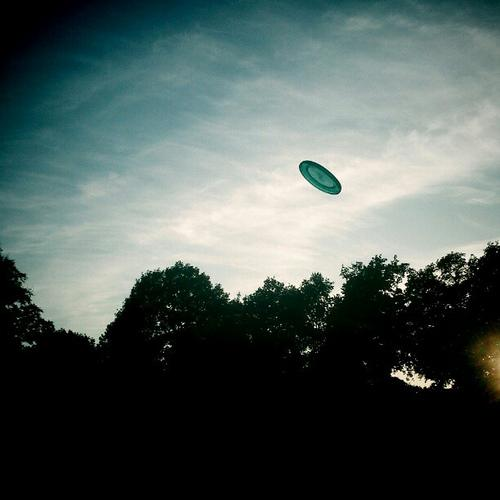How would you describe the appearance of the sky in the image? The sky is dark, grey, and cloudy with streaks of white clouds at high altitude. Can you describe the light conditions present in the image? The light conditions have a glimmer of sunlight shining through the dense trees, with light shining on the trees and dark fade on the corners of the photo. What is the color of the frisbee and what shape does it have? The frisbee is green in color and has a round, circular shape. Can you count the number of circular objects in the image? There are two circular objects: a green frisbee and its inner circle. What is flying in the air above the trees? A round green frisbee with an inner circle is in mid-air above the trees. What unique aspect of the frisbee's outlook changes depending on the angle it is viewed from? Depending on the angle it is viewed from, the frisbee may appear oval or circular, and it can be seen from underneath. How would you summarize the overall sentiment of the image? The image has a tranquil and serene sentiment with focus on the frisbee flying through the air, surrounded by a beautiful, dense forest and a moody, cloudy sky. Identify the type of trees present in the image. The trees are deciduous with green leaves. Describe the position of the frisbee in relation to the trees. The frisbee is flying in mid-air above the tree line with a small break in the tree line visible beneath it. Mention the key elements in the image related to nature. The key elements related to nature are the dense green trees, the grassy area of the park, and the cloudy sky. Describe the interaction taking place between the frisbee and its surroundings. The frisbee is flying across the air, interacting with the air currents and hovering above the tree line. Does the frisbee image suggest it is moving or stationary? The frisbee is moving as it is in mid air, flying across the air. Which phrase identifies the location of the frisbee? Frisbee flying above tree line Explain the relationship between the trees and the sunlight in the image. The sunlight is shining through the trees, causing light to hit the grassy area and create shadows. Based on the descriptions, provide a semantic segmentation of the image. Sky: gray, cloudy, dark blue; Frisbee: green, round, in air; Trees: green, dense, deciduous; Grass: green; Sunlight: glimmer, shining through trees. Are there any unusual or unexpected elements in the image? No, the image has elements commonly found in a natural outdoor setting. What color is the hot air balloon floating above the trees? The image details do not include any information about a hot air balloon, so this question is misleading as it implies a non-existent object. What is the main point of interest in the image? The main point of interest is the green frisbee flying above the tree line. Determine the quality of the image considering lighting, contrast, and sharpness.  The image has good quality, with decent lighting, adequate contrast, and clear sharpness. In the image, what is the position of the frisbee relative to the tree line? The frisbee is located above the tree line. Locate the bench in the park and describe its color. While there is mention of a "grassy area of park," there is no explicit mention of a bench in the image. This instruction is misleading, as it asks for specifics about a non-existent object. What color are the clouds in the sky? The clouds in the sky are white. How would you describe the area below the frisbee? The area below the frisbee is a grassy part of the park with dense trees in the background. What are some attributes of the frisbee in the image? The frisbee is green, round, and circular in shape, with a black inner circle. Identify the man wearing a red shirt, who's trying to catch the frisbee. There is no mention of a person, especially someone wearing a red shirt or attempting to catch a frisbee, in the image information. Thus, this instruction is misleading as it suggests the presence of a person who doesn't exist in the image. Indicate the position of the full moon in the cloudy sky. The image details discuss the sky, clouds, and darkness, but there is no mention of a full moon. This instruction is misleading as it suggests the presence of a full moon that isn't present in the image. Are there any written words or text in the image? No, there is no text or written words in the image. Describe the shape and color of the frisbee. The frisbee is round and green, with a circular shape. Please point out the flamingo standing by the water's edge. There is no mention of a flamingo or water in the given image details, which makes this instruction misleading. What is the state of the trees in the background? The trees in the background are green, dense, and deciduous with leaves. Describe the scene in the image focusing on the sky. The sky is gray and cloudy, with streaks of white clouds at high altitude and a dark blue hue. Are there any indications of strong wind in the image? No, there are no indications of strong wind in the image. Can you spot the squirrel climbing one of the trees in the background? Although the image contains numerous details about the trees, there is no mention of any animals, specifically a squirrel. This question is misleading, as it implies the existence of a squirrel not referenced in the image details. What object is seen flying above the tree line? A frisbee is in mid air, flying above the tree line. Identify the sentiment of the image based on the overall visual appearance.  The sentiment is calm and serene, due to the natural scenery and cloudy sky. 